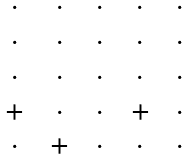Convert formula to latex. <formula><loc_0><loc_0><loc_500><loc_500>\begin{matrix} \, \cdot \, & \, \cdot \, & \, \cdot \, & \, \cdot \, & \, \cdot \, \\ \, \cdot \, & \, \cdot \, & \, \cdot \, & \, \cdot \, & \, \cdot \, \\ \, \cdot \, & \, \cdot \, & \, \cdot \, & \, \cdot \, & \, \cdot \, \\ \, + \, & \, \cdot \, & \, \cdot \, & \, + \, & \, \cdot \, \\ \, \cdot \, & \, + \, & \, \cdot \, & \, \cdot \, & \, \cdot \, \\ \end{matrix}</formula> 